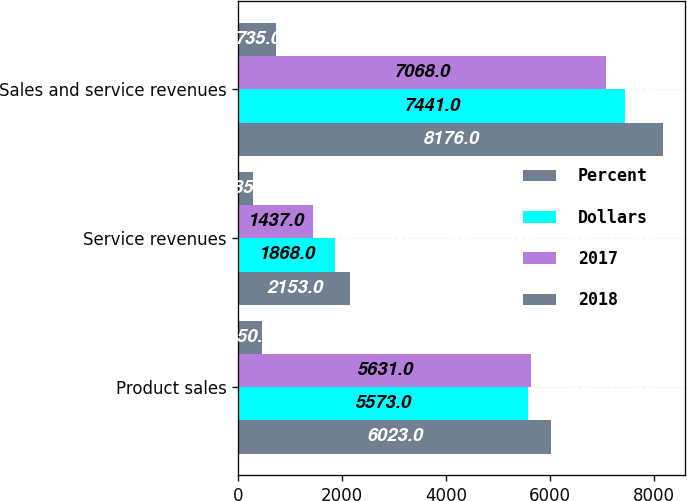<chart> <loc_0><loc_0><loc_500><loc_500><stacked_bar_chart><ecel><fcel>Product sales<fcel>Service revenues<fcel>Sales and service revenues<nl><fcel>Percent<fcel>6023<fcel>2153<fcel>8176<nl><fcel>Dollars<fcel>5573<fcel>1868<fcel>7441<nl><fcel>2017<fcel>5631<fcel>1437<fcel>7068<nl><fcel>2018<fcel>450<fcel>285<fcel>735<nl></chart> 